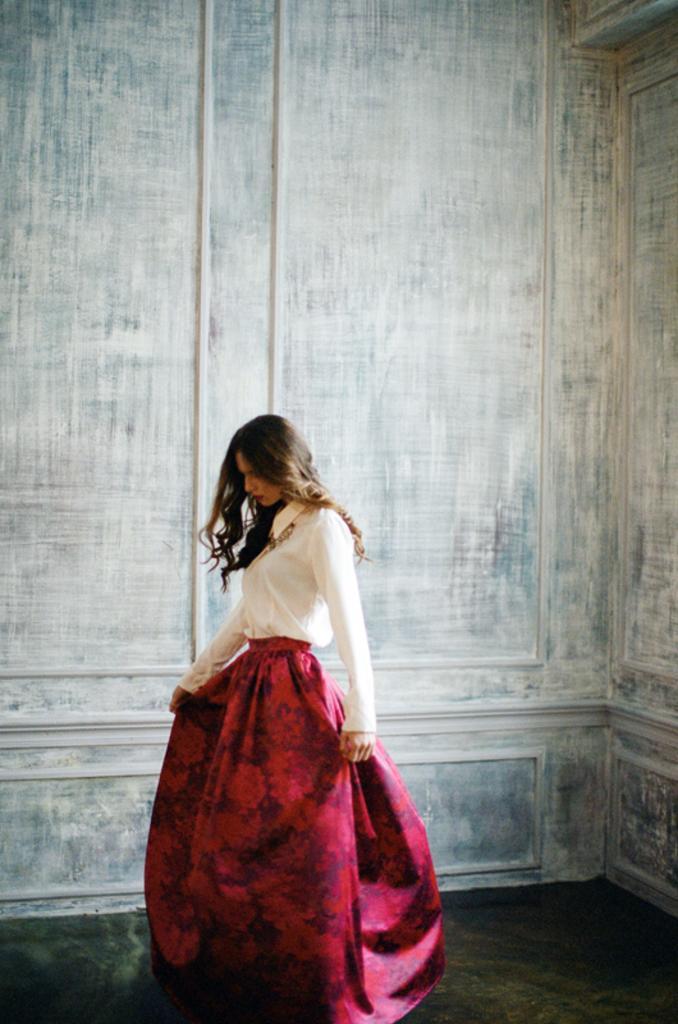Could you give a brief overview of what you see in this image? This picture is taken inside the room. In this image, in the middle, we can see a woman standing on the floor. In the background, we can see a floor. 